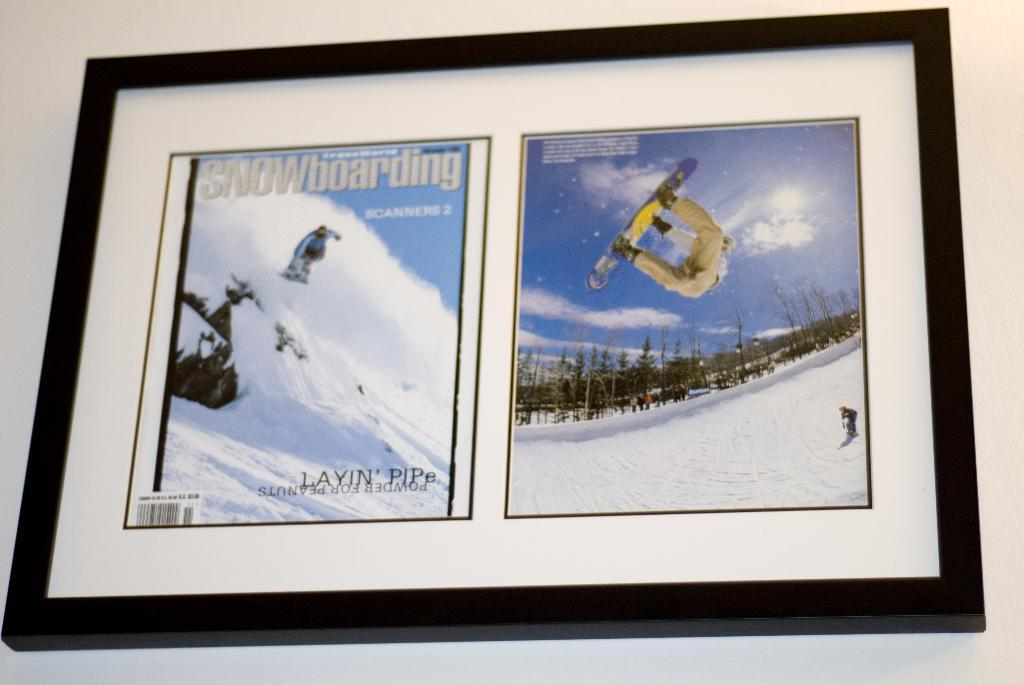<image>
Summarize the visual content of the image. Two framed pictures of snowboarders with "Snowboarding" written on one of them. 